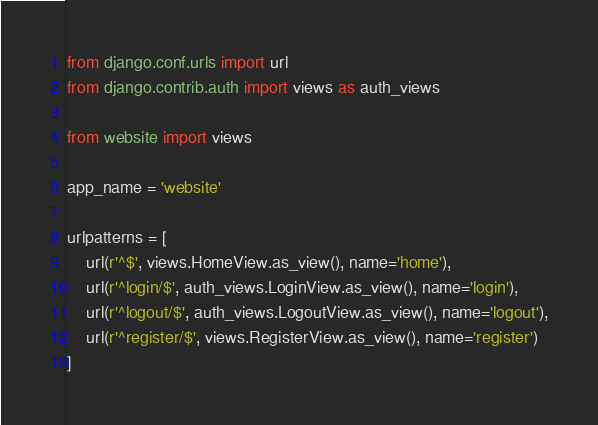<code> <loc_0><loc_0><loc_500><loc_500><_Python_>from django.conf.urls import url
from django.contrib.auth import views as auth_views

from website import views

app_name = 'website'

urlpatterns = [
    url(r'^$', views.HomeView.as_view(), name='home'),
    url(r'^login/$', auth_views.LoginView.as_view(), name='login'),
    url(r'^logout/$', auth_views.LogoutView.as_view(), name='logout'),
    url(r'^register/$', views.RegisterView.as_view(), name='register')
]
</code> 